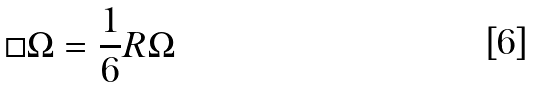<formula> <loc_0><loc_0><loc_500><loc_500>\square \Omega = \frac { 1 } { 6 } R \Omega</formula> 